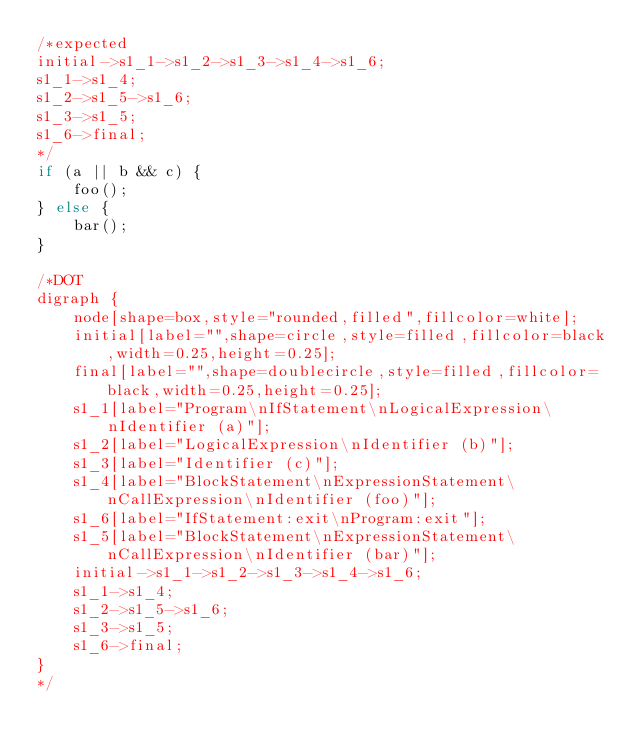Convert code to text. <code><loc_0><loc_0><loc_500><loc_500><_JavaScript_>/*expected
initial->s1_1->s1_2->s1_3->s1_4->s1_6;
s1_1->s1_4;
s1_2->s1_5->s1_6;
s1_3->s1_5;
s1_6->final;
*/
if (a || b && c) {
    foo();
} else {
    bar();
}

/*DOT
digraph {
    node[shape=box,style="rounded,filled",fillcolor=white];
    initial[label="",shape=circle,style=filled,fillcolor=black,width=0.25,height=0.25];
    final[label="",shape=doublecircle,style=filled,fillcolor=black,width=0.25,height=0.25];
    s1_1[label="Program\nIfStatement\nLogicalExpression\nIdentifier (a)"];
    s1_2[label="LogicalExpression\nIdentifier (b)"];
    s1_3[label="Identifier (c)"];
    s1_4[label="BlockStatement\nExpressionStatement\nCallExpression\nIdentifier (foo)"];
    s1_6[label="IfStatement:exit\nProgram:exit"];
    s1_5[label="BlockStatement\nExpressionStatement\nCallExpression\nIdentifier (bar)"];
    initial->s1_1->s1_2->s1_3->s1_4->s1_6;
    s1_1->s1_4;
    s1_2->s1_5->s1_6;
    s1_3->s1_5;
    s1_6->final;
}
*/
</code> 